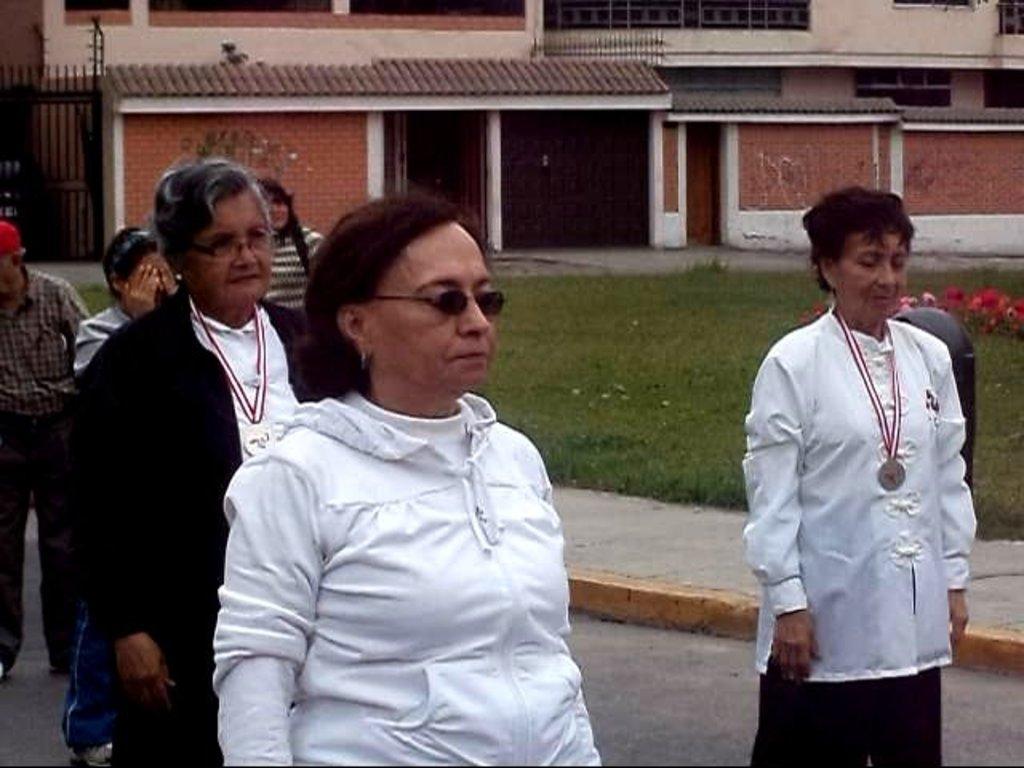Can you describe this image briefly? In this picture there is a woman who is wearing white jacket and goggles. Beside her we can see an old woman who is wearing a black jacket. On the right there is another woman who is wearing white jacket and medal. On the left background we can see three person standing on the road. In the background we can see building. On the top left there is a steel gate. On the right we can see flowers and grass. 